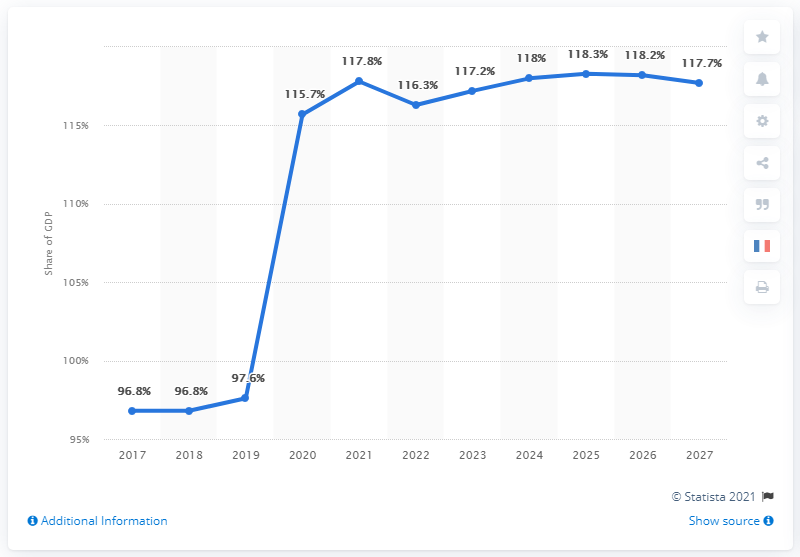Specify some key components in this picture. The change in public debt in France between the years 2020 and 2019 was 18.1%. The estimated public debt in France for the year 2021 is projected to be 117.7%. In 2019, public debt accounted for approximately 97.6% of France's GDP. In the year 2017, the public debt in France was approximately 96.8%. 